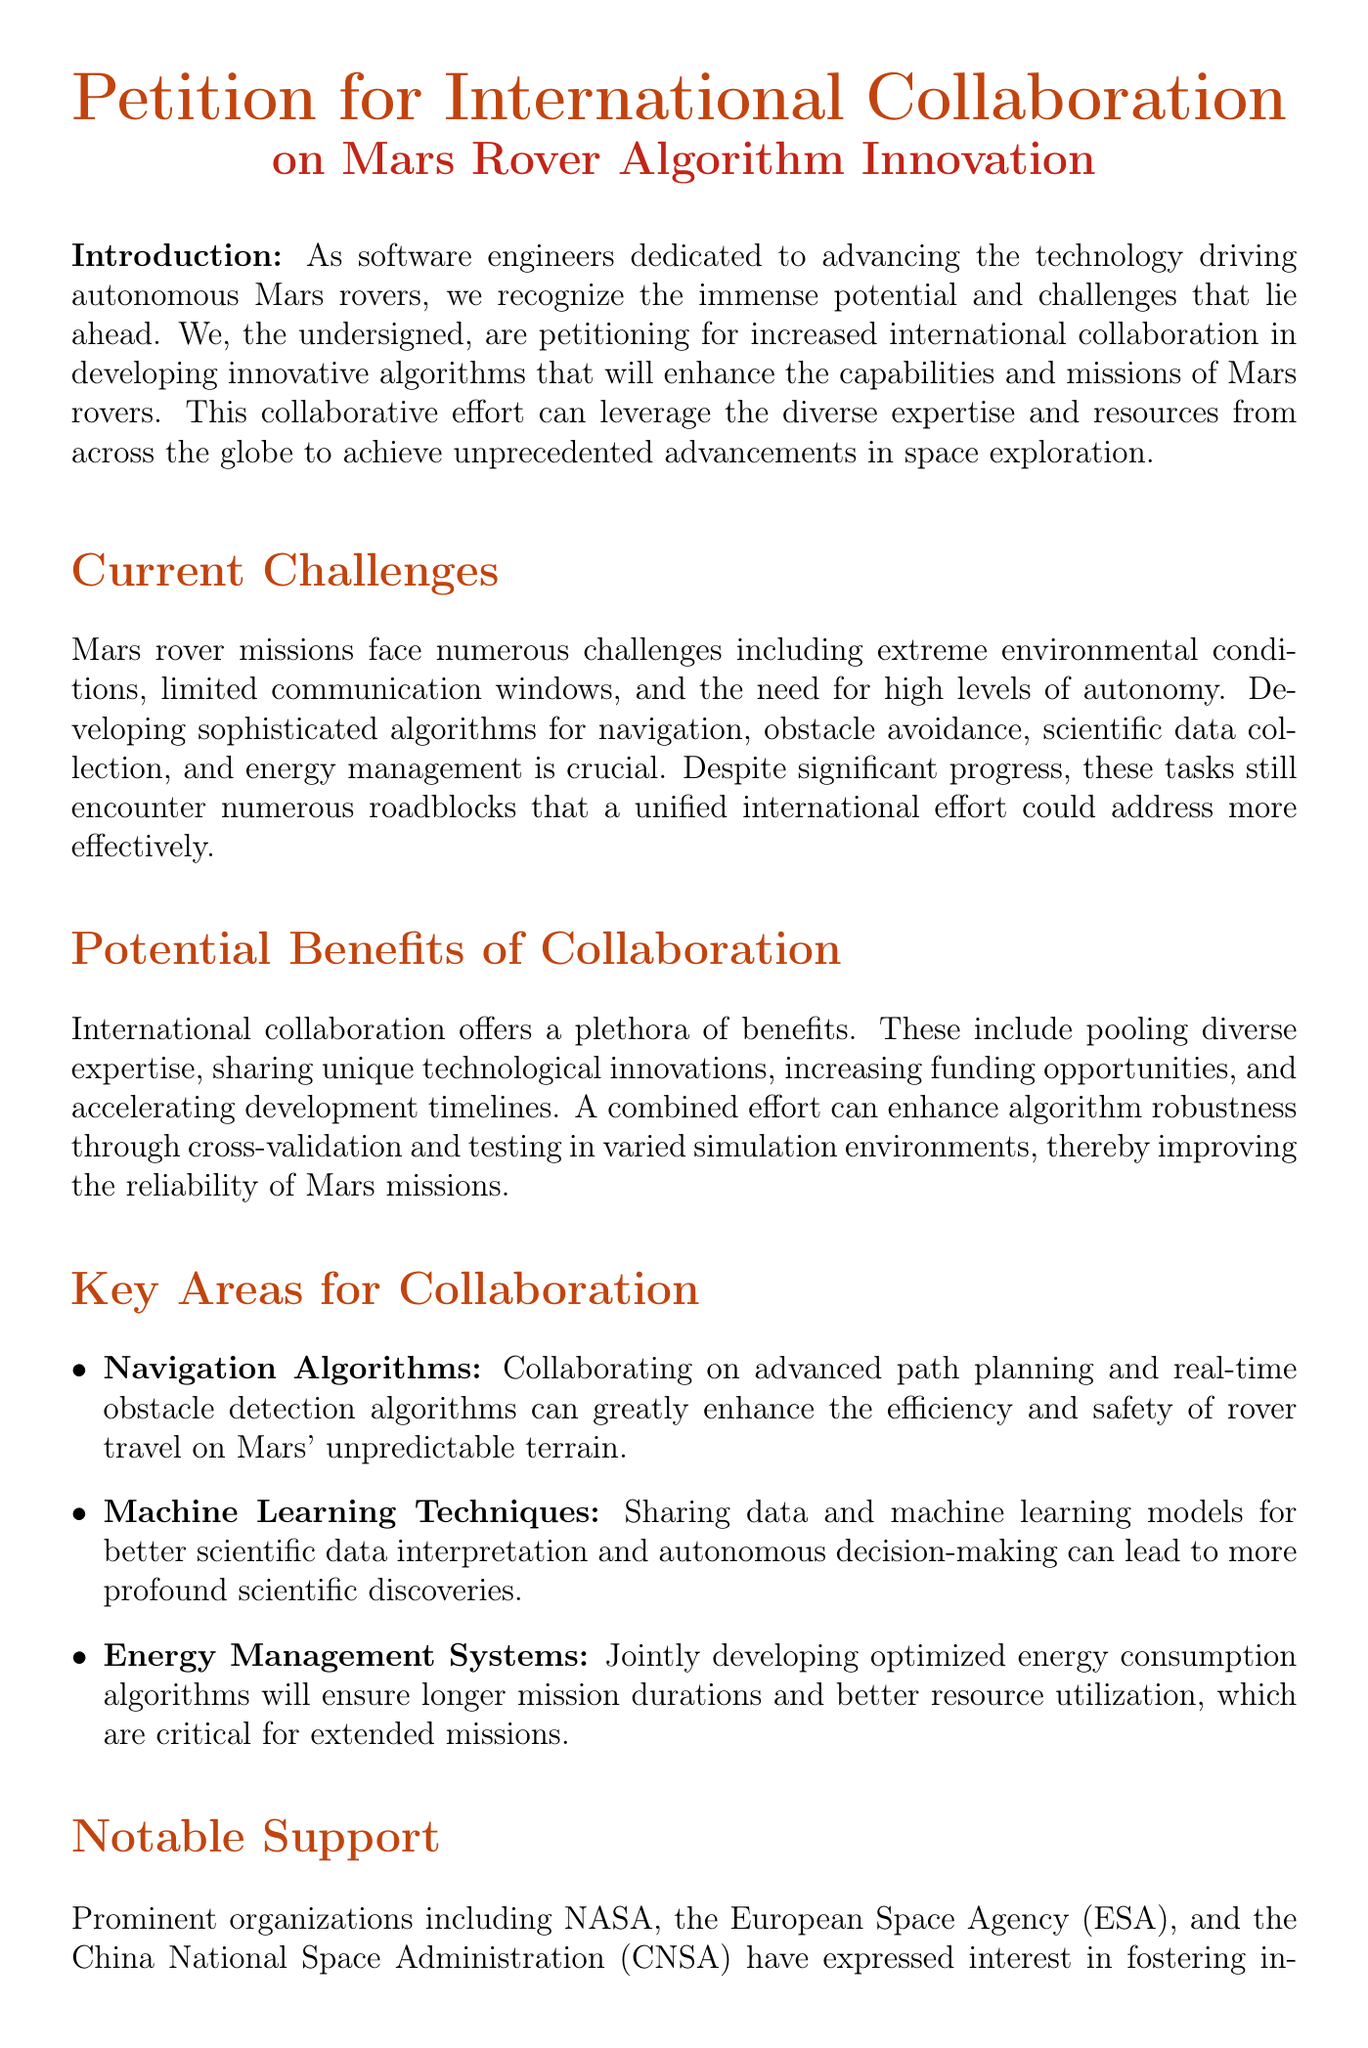What is the title of the petition? The title of the petition is a significant detail that can be found at the beginning of the document.
Answer: Petition for International Collaboration on Mars Rover Algorithm Innovation Who is the lead signatory of the petition? The lead signatory is mentioned at the end of the document, providing their name and title.
Answer: Alex Johnson What organizations have shown interest in this collaboration? The petition lists several prominent organizations that support the initiative and are interested in collaboration.
Answer: NASA, ESA, CNSA What key area for collaboration focuses on navigation? The document outlines several areas for collaboration, one of which directly relates to navigation technologies.
Answer: Navigation Algorithms What is one expected benefit of international collaboration? The petition highlights various advantages of collaboration, focusing on shared resources and expertise.
Answer: Pooling diverse expertise What email address is provided for contact in the document? The document contains a specific point of contact for further inquiries and communication.
Answer: alex.johnson@marsroverdev.org How many notable support organizations are mentioned? The document references a number of notable organizations that support the initiative, which reflects the level of interest.
Answer: Five What does the petition urge various entities to do? The petition includes a call to action for specific entities regarding their involvement in the initiative.
Answer: Join forces 